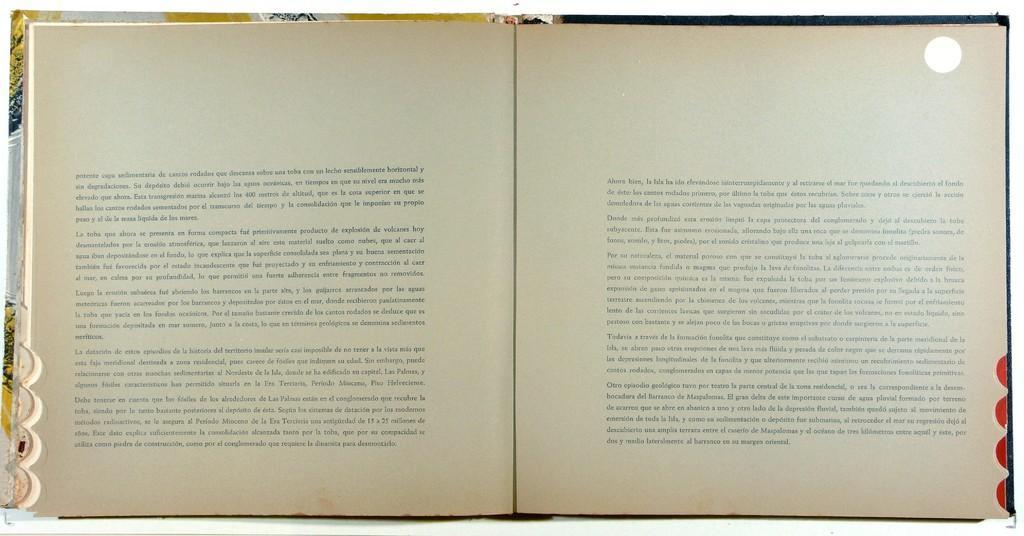Please provide a concise description of this image. In this image there is a book which is opened where we can see the script. 